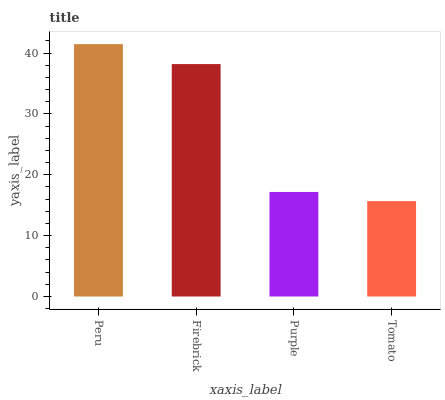Is Firebrick the minimum?
Answer yes or no. No. Is Firebrick the maximum?
Answer yes or no. No. Is Peru greater than Firebrick?
Answer yes or no. Yes. Is Firebrick less than Peru?
Answer yes or no. Yes. Is Firebrick greater than Peru?
Answer yes or no. No. Is Peru less than Firebrick?
Answer yes or no. No. Is Firebrick the high median?
Answer yes or no. Yes. Is Purple the low median?
Answer yes or no. Yes. Is Tomato the high median?
Answer yes or no. No. Is Tomato the low median?
Answer yes or no. No. 